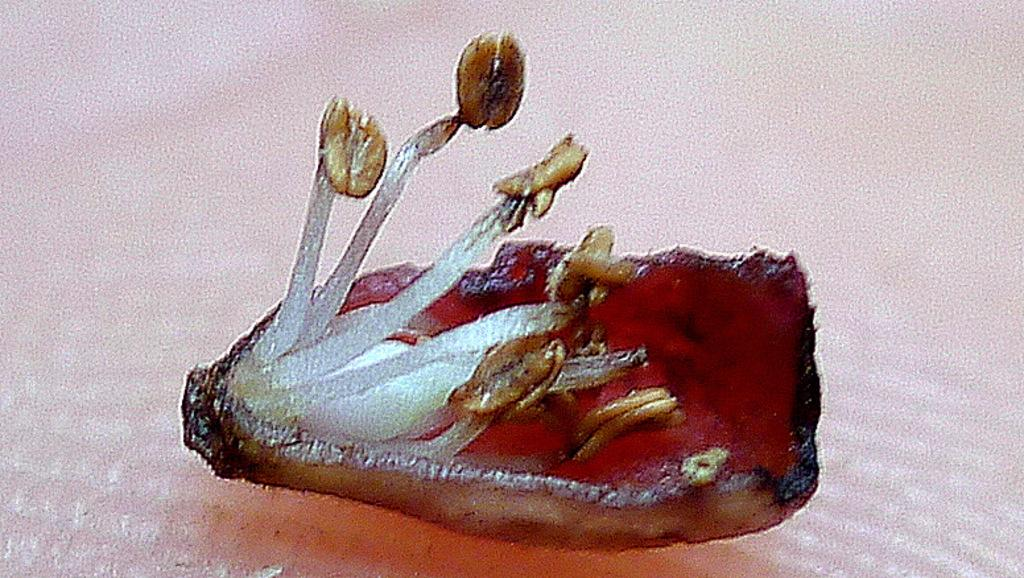What is the main subject of the image? The main subject of the image is a part of a flower. Can you describe a specific part of the flower that is visible in the image? There is a petal visible in the image. What can be found on the petal in the image? There are pollen grains in the image. How many laborers are working in the image? There are no laborers present in the image; it features a part of a flower with a petal and pollen grains. What is the chance of winning a prize in the image? There is no reference to a prize or chance in the image, as it focuses on a part of a flower with a petal and pollen grains. 